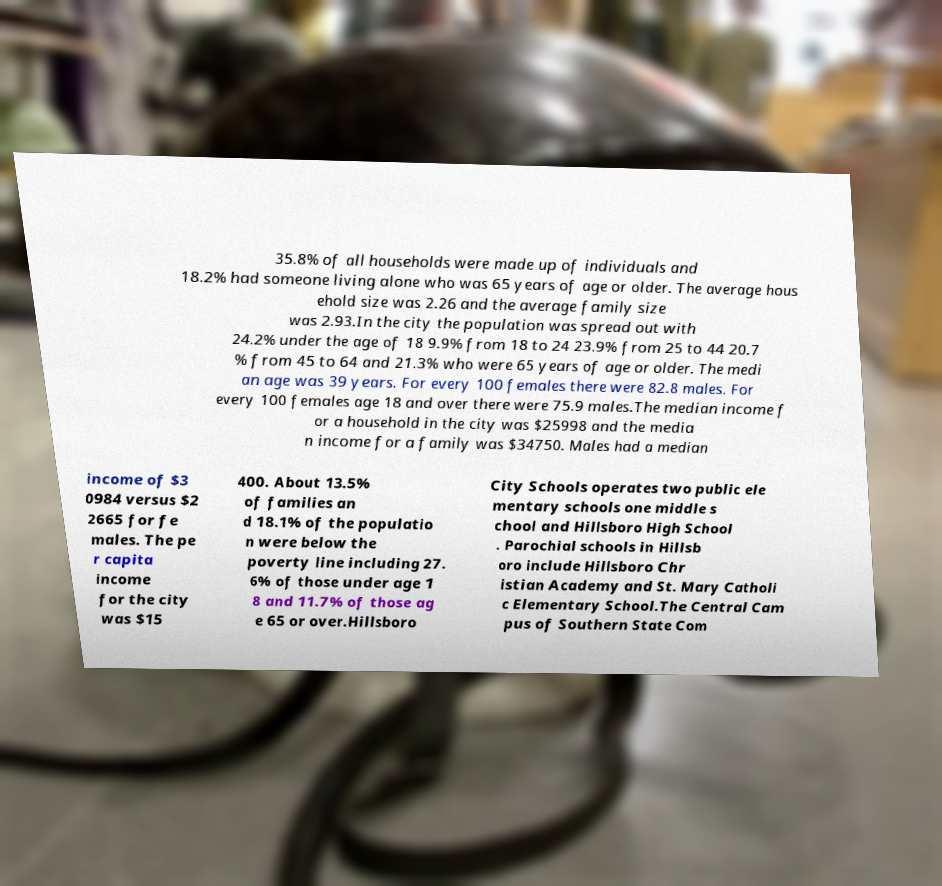For documentation purposes, I need the text within this image transcribed. Could you provide that? 35.8% of all households were made up of individuals and 18.2% had someone living alone who was 65 years of age or older. The average hous ehold size was 2.26 and the average family size was 2.93.In the city the population was spread out with 24.2% under the age of 18 9.9% from 18 to 24 23.9% from 25 to 44 20.7 % from 45 to 64 and 21.3% who were 65 years of age or older. The medi an age was 39 years. For every 100 females there were 82.8 males. For every 100 females age 18 and over there were 75.9 males.The median income f or a household in the city was $25998 and the media n income for a family was $34750. Males had a median income of $3 0984 versus $2 2665 for fe males. The pe r capita income for the city was $15 400. About 13.5% of families an d 18.1% of the populatio n were below the poverty line including 27. 6% of those under age 1 8 and 11.7% of those ag e 65 or over.Hillsboro City Schools operates two public ele mentary schools one middle s chool and Hillsboro High School . Parochial schools in Hillsb oro include Hillsboro Chr istian Academy and St. Mary Catholi c Elementary School.The Central Cam pus of Southern State Com 